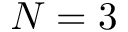<formula> <loc_0><loc_0><loc_500><loc_500>N = 3</formula> 